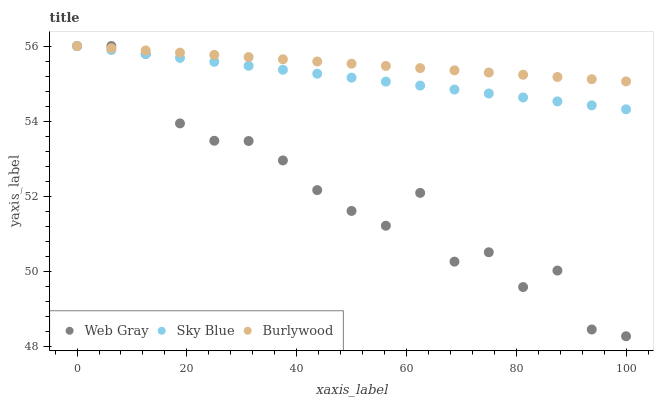Does Web Gray have the minimum area under the curve?
Answer yes or no. Yes. Does Burlywood have the maximum area under the curve?
Answer yes or no. Yes. Does Sky Blue have the minimum area under the curve?
Answer yes or no. No. Does Sky Blue have the maximum area under the curve?
Answer yes or no. No. Is Burlywood the smoothest?
Answer yes or no. Yes. Is Web Gray the roughest?
Answer yes or no. Yes. Is Sky Blue the smoothest?
Answer yes or no. No. Is Sky Blue the roughest?
Answer yes or no. No. Does Web Gray have the lowest value?
Answer yes or no. Yes. Does Sky Blue have the lowest value?
Answer yes or no. No. Does Web Gray have the highest value?
Answer yes or no. Yes. Does Web Gray intersect Sky Blue?
Answer yes or no. Yes. Is Web Gray less than Sky Blue?
Answer yes or no. No. Is Web Gray greater than Sky Blue?
Answer yes or no. No. 